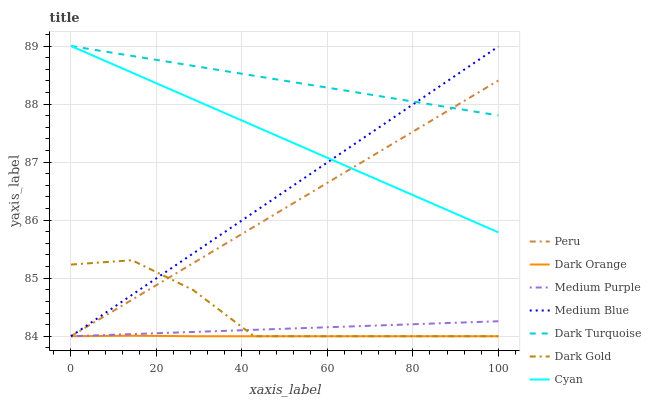Does Dark Orange have the minimum area under the curve?
Answer yes or no. Yes. Does Dark Turquoise have the maximum area under the curve?
Answer yes or no. Yes. Does Dark Gold have the minimum area under the curve?
Answer yes or no. No. Does Dark Gold have the maximum area under the curve?
Answer yes or no. No. Is Medium Purple the smoothest?
Answer yes or no. Yes. Is Dark Gold the roughest?
Answer yes or no. Yes. Is Dark Turquoise the smoothest?
Answer yes or no. No. Is Dark Turquoise the roughest?
Answer yes or no. No. Does Dark Turquoise have the lowest value?
Answer yes or no. No. Does Cyan have the highest value?
Answer yes or no. Yes. Does Dark Gold have the highest value?
Answer yes or no. No. Is Dark Orange less than Cyan?
Answer yes or no. Yes. Is Dark Turquoise greater than Dark Gold?
Answer yes or no. Yes. Does Dark Orange intersect Cyan?
Answer yes or no. No. 